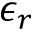Convert formula to latex. <formula><loc_0><loc_0><loc_500><loc_500>\epsilon _ { r }</formula> 